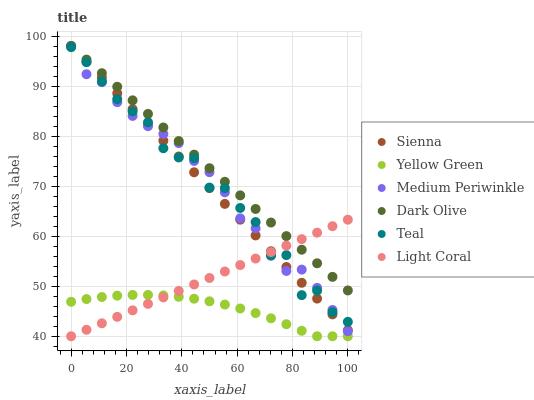Does Yellow Green have the minimum area under the curve?
Answer yes or no. Yes. Does Dark Olive have the maximum area under the curve?
Answer yes or no. Yes. Does Dark Olive have the minimum area under the curve?
Answer yes or no. No. Does Yellow Green have the maximum area under the curve?
Answer yes or no. No. Is Sienna the smoothest?
Answer yes or no. Yes. Is Teal the roughest?
Answer yes or no. Yes. Is Yellow Green the smoothest?
Answer yes or no. No. Is Yellow Green the roughest?
Answer yes or no. No. Does Light Coral have the lowest value?
Answer yes or no. Yes. Does Dark Olive have the lowest value?
Answer yes or no. No. Does Sienna have the highest value?
Answer yes or no. Yes. Does Yellow Green have the highest value?
Answer yes or no. No. Is Teal less than Dark Olive?
Answer yes or no. Yes. Is Teal greater than Yellow Green?
Answer yes or no. Yes. Does Light Coral intersect Medium Periwinkle?
Answer yes or no. Yes. Is Light Coral less than Medium Periwinkle?
Answer yes or no. No. Is Light Coral greater than Medium Periwinkle?
Answer yes or no. No. Does Teal intersect Dark Olive?
Answer yes or no. No. 